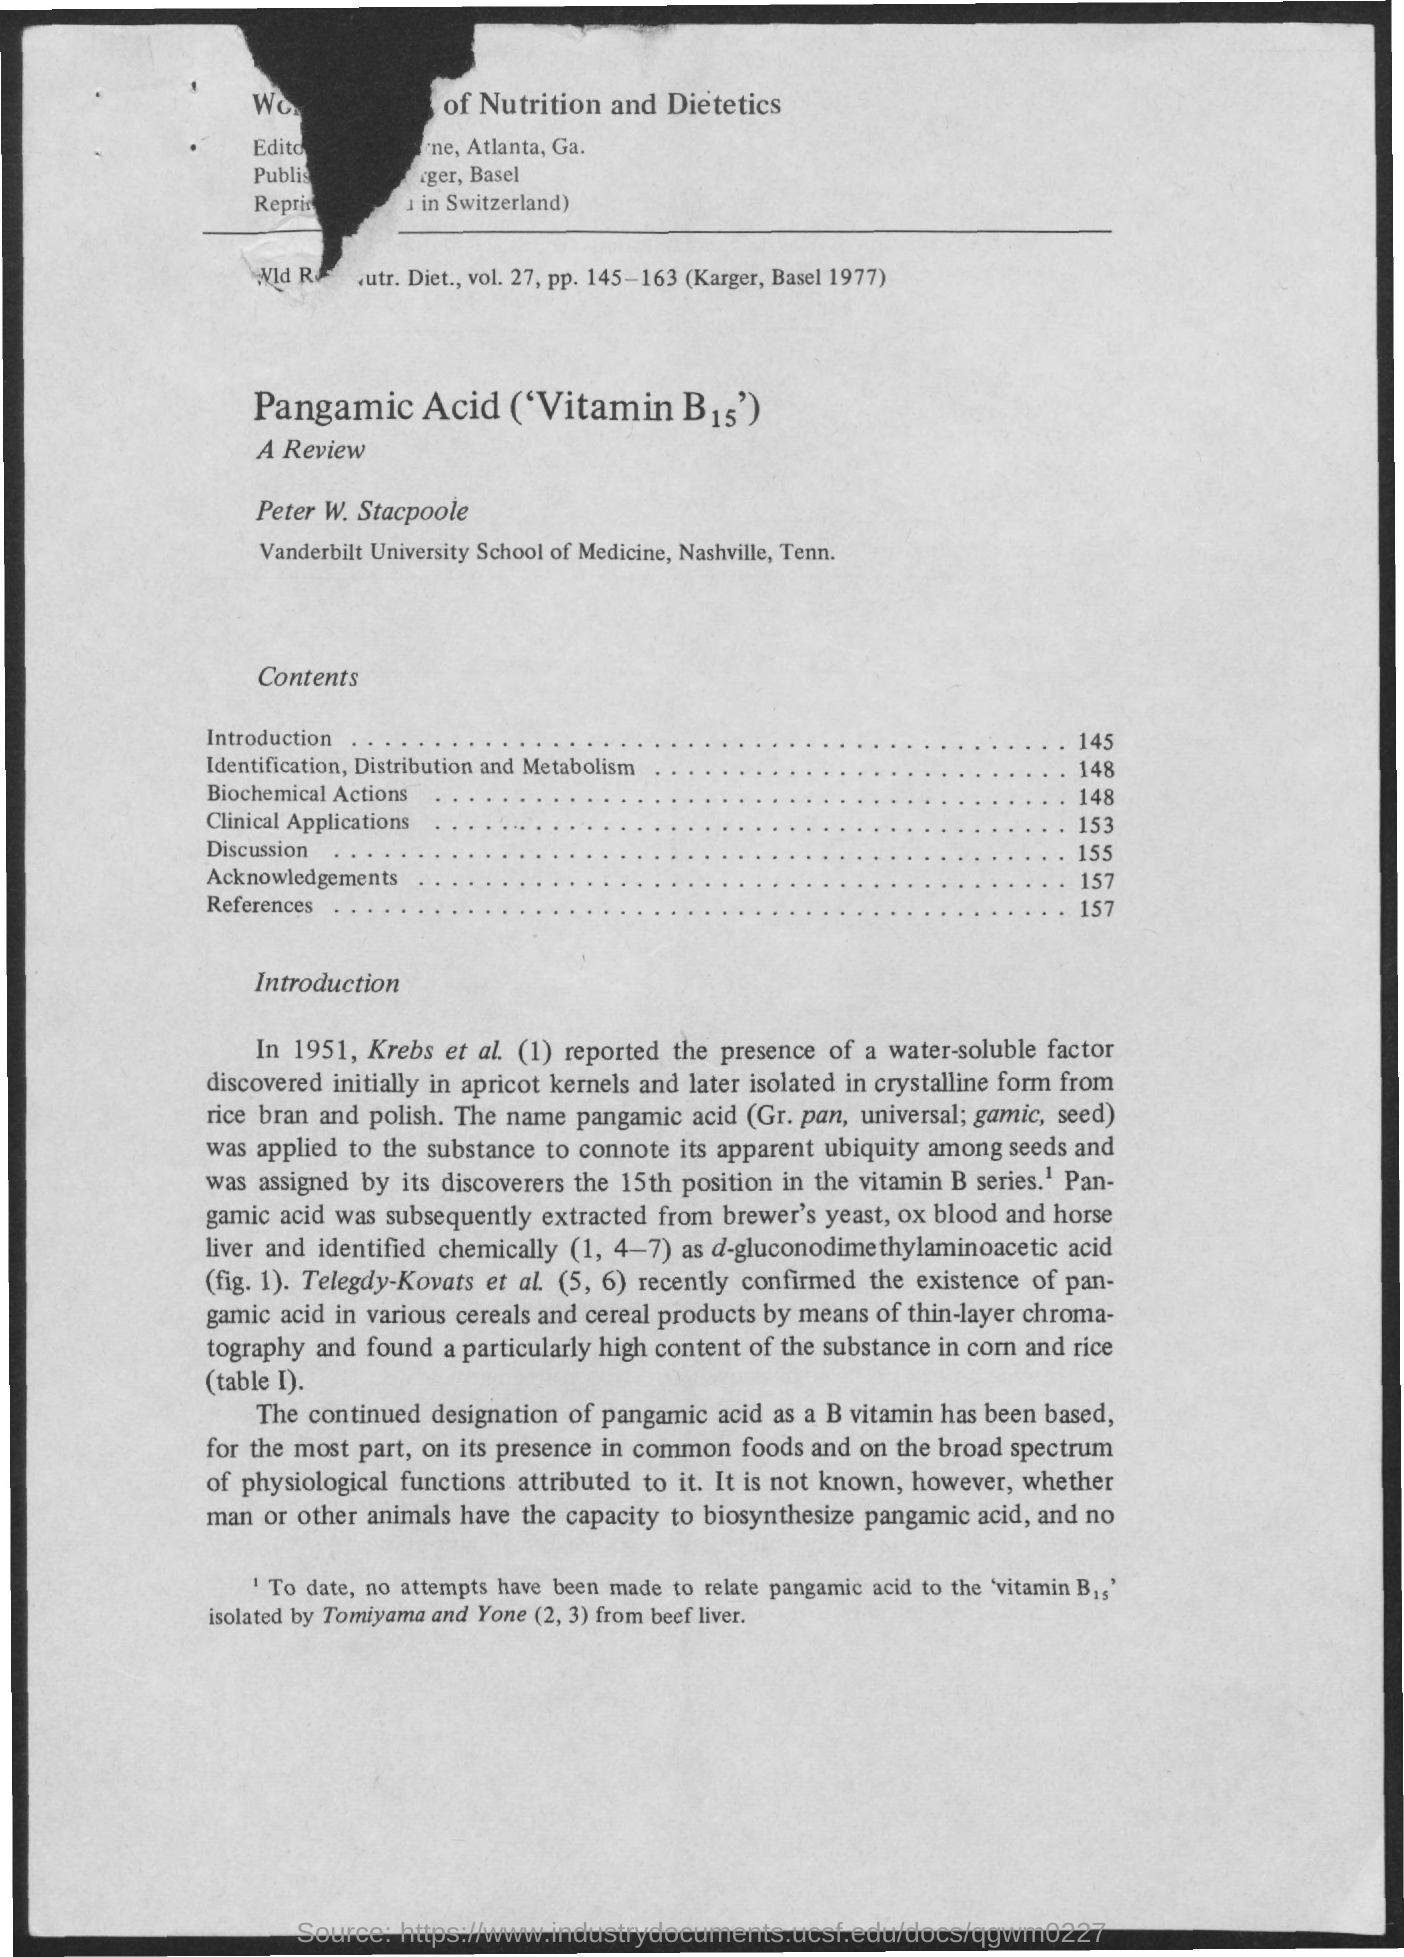Indicate a few pertinent items in this graphic. The page number for references is 157. The page number for discussion is 155. The page number for clinical applications is 153. The page number for the Acknowledgements is 157. The page number for biochemical actions is 148. 